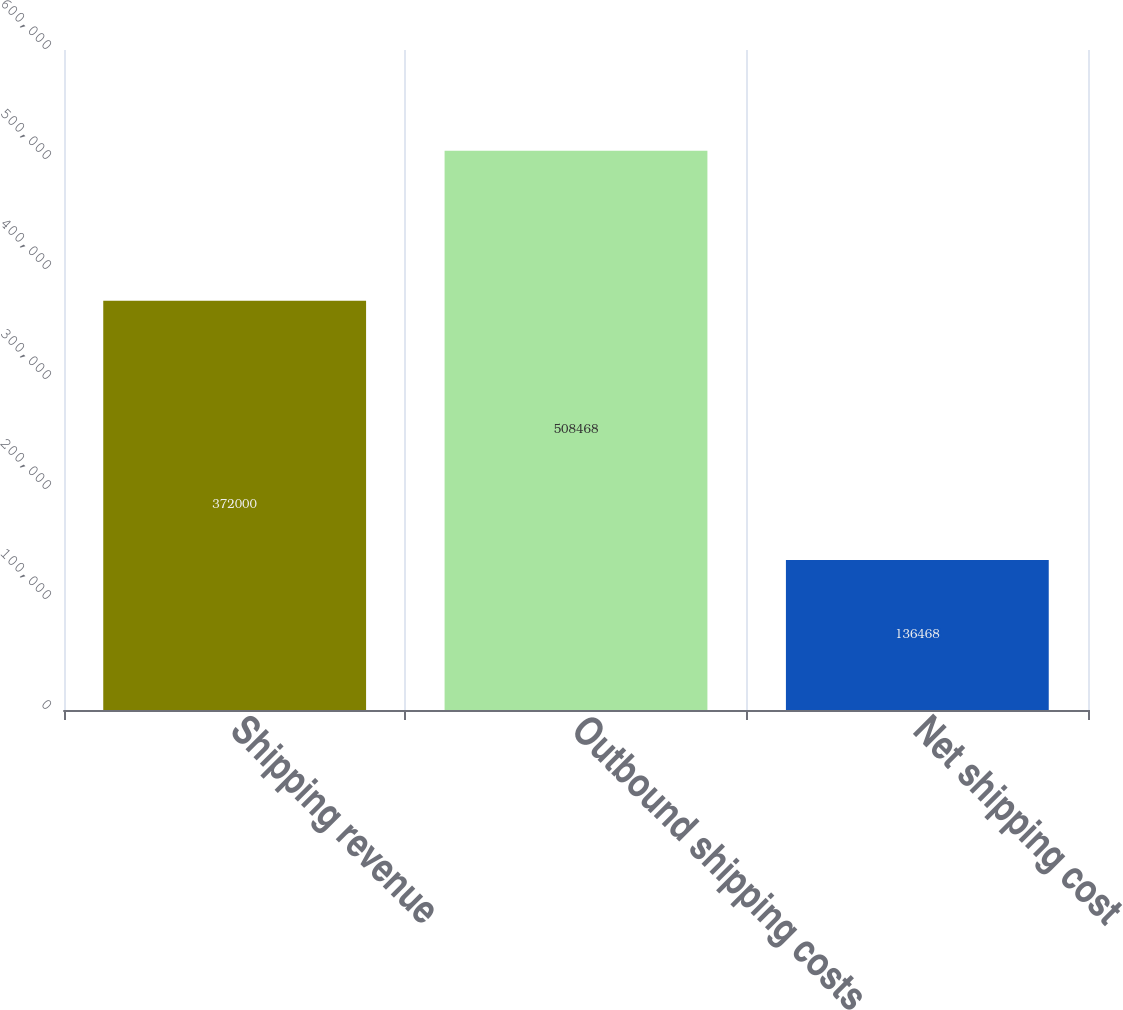Convert chart. <chart><loc_0><loc_0><loc_500><loc_500><bar_chart><fcel>Shipping revenue<fcel>Outbound shipping costs<fcel>Net shipping cost<nl><fcel>372000<fcel>508468<fcel>136468<nl></chart> 